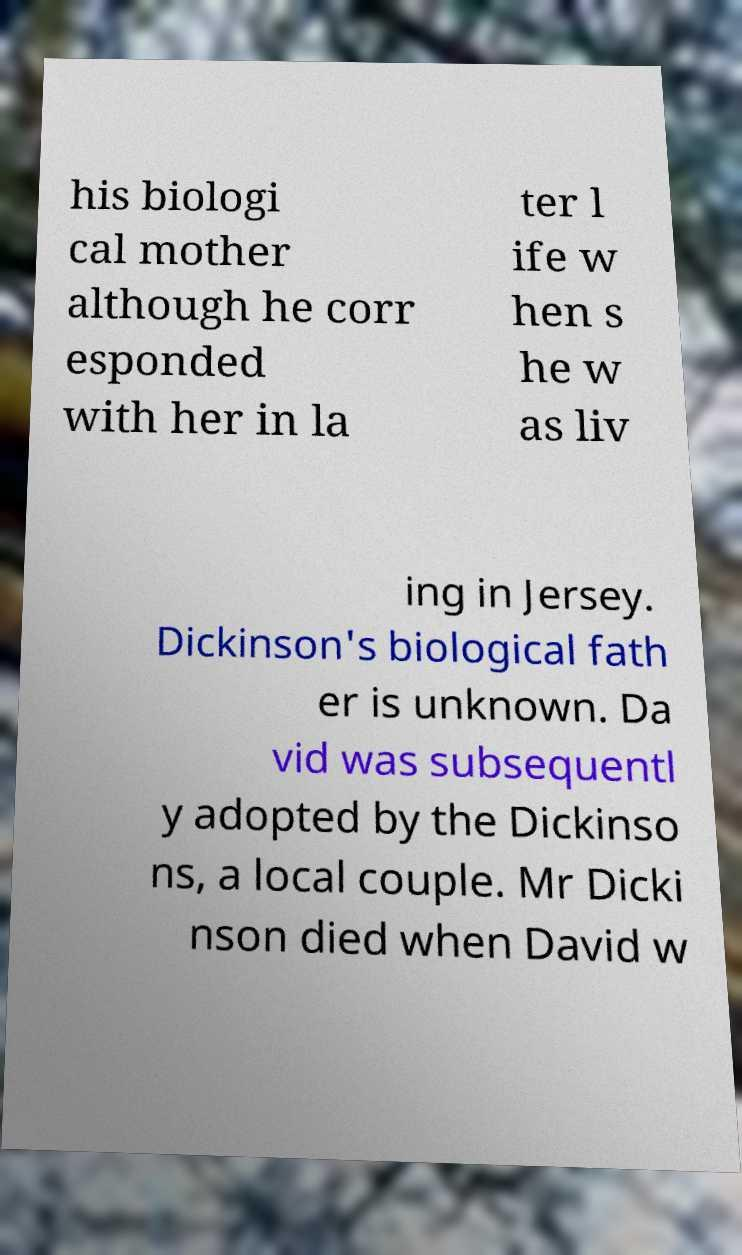What messages or text are displayed in this image? I need them in a readable, typed format. his biologi cal mother although he corr esponded with her in la ter l ife w hen s he w as liv ing in Jersey. Dickinson's biological fath er is unknown. Da vid was subsequentl y adopted by the Dickinso ns, a local couple. Mr Dicki nson died when David w 